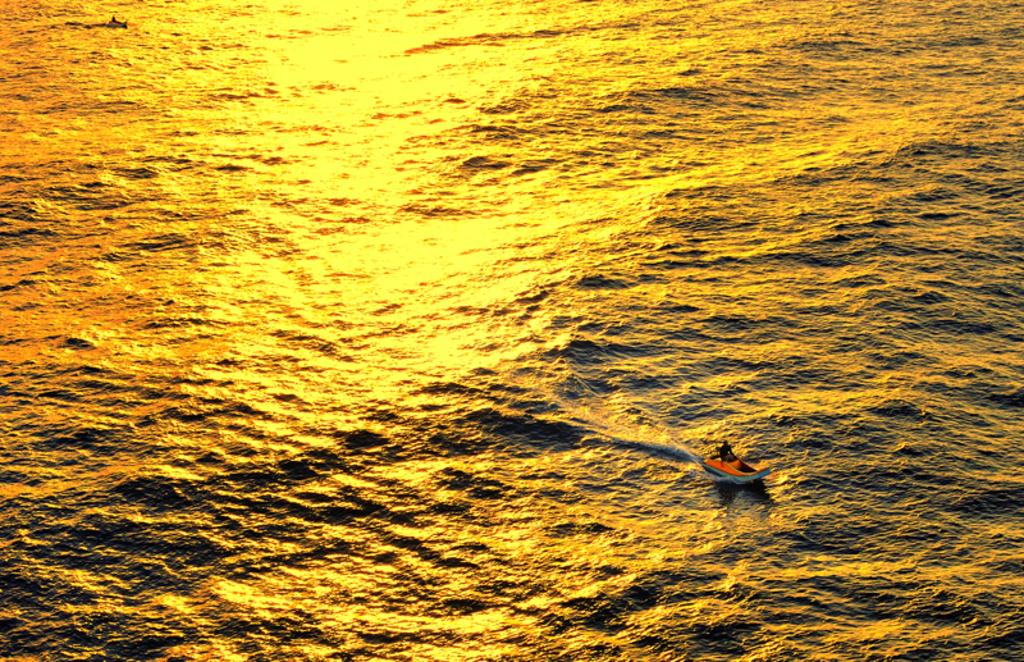Who or what is in the image? There is a person in the image. What is the person doing or where are they located? The person is on a boat. What can be seen in the background of the image? There is water visible in the background of the image. What type of fang can be seen in the image? There is no fang present in the image; it features a person on a boat with water in the background. 